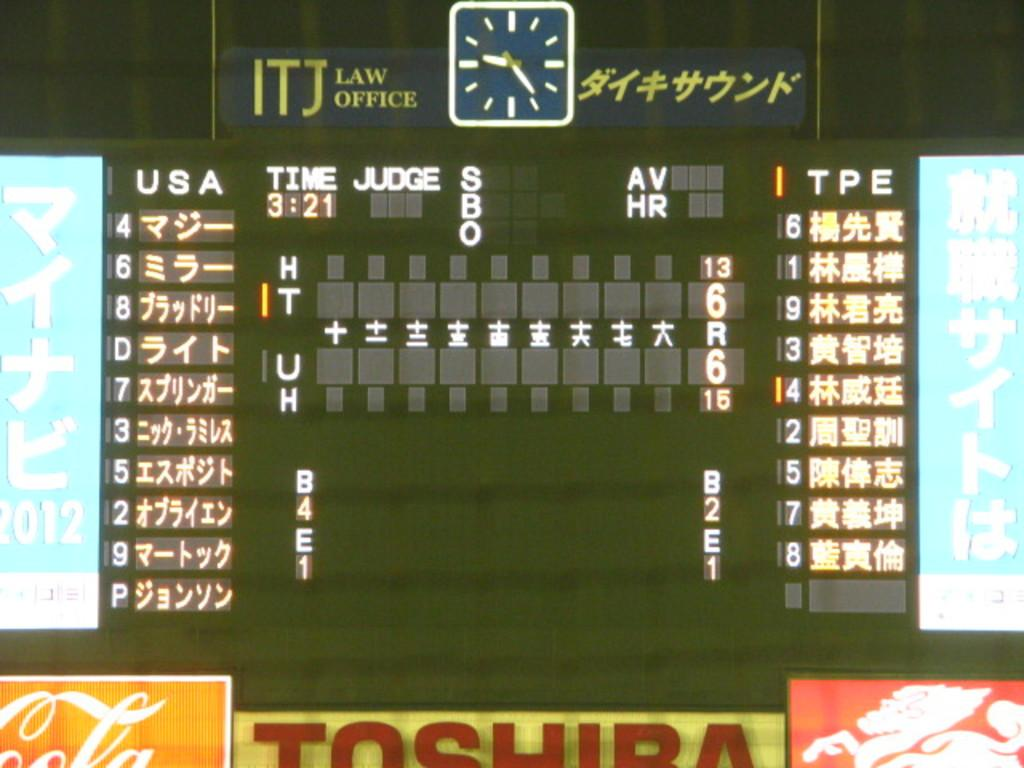<image>
Render a clear and concise summary of the photo. A scoreboard which advertises the company Toshiba at the bottom. 